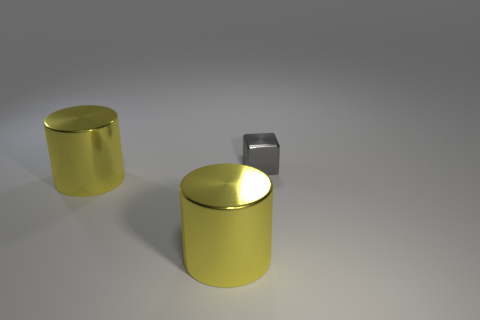What number of other objects are the same size as the gray cube?
Provide a succinct answer. 0. What number of big things are either cylinders or cubes?
Your answer should be very brief. 2. Is there any other thing that has the same color as the tiny shiny cube?
Offer a very short reply. No. Is there anything else that has the same material as the block?
Offer a terse response. Yes. Are there the same number of yellow cylinders that are in front of the small block and cylinders?
Your answer should be very brief. Yes. The small gray shiny thing has what shape?
Offer a terse response. Cube. How many gray metallic objects have the same size as the gray metal block?
Your response must be concise. 0. What color is the shiny block?
Give a very brief answer. Gray. Are there any big blocks that have the same color as the tiny cube?
Keep it short and to the point. No. What number of things are either metal things left of the tiny gray shiny thing or gray objects?
Make the answer very short. 3. 